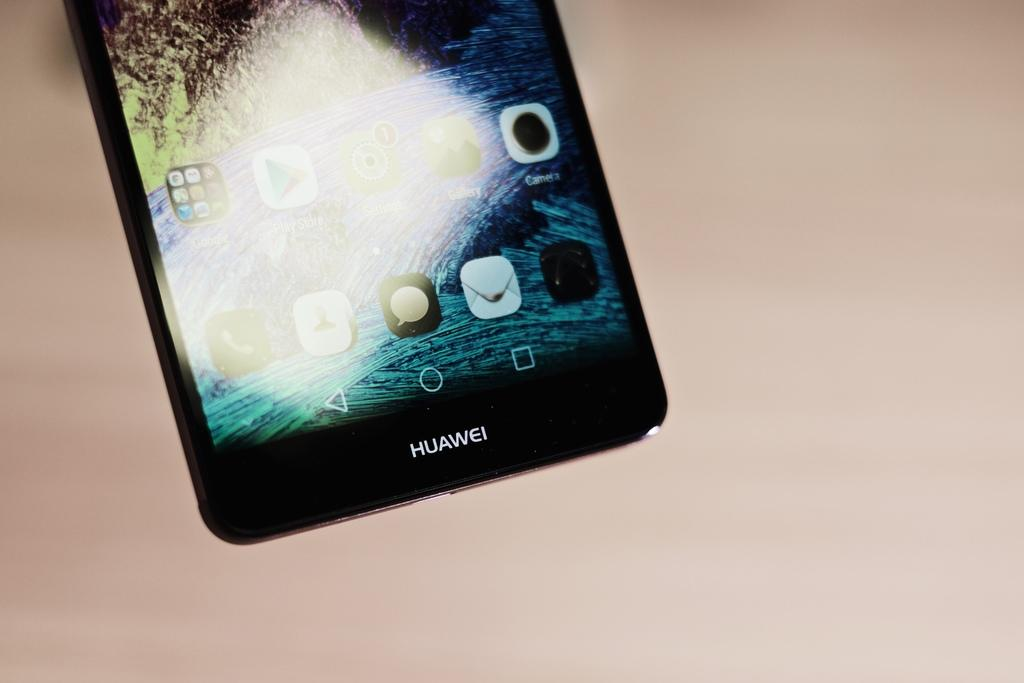<image>
Offer a succinct explanation of the picture presented. Bottom half of a Huawei phone lays on a light pink surface. 